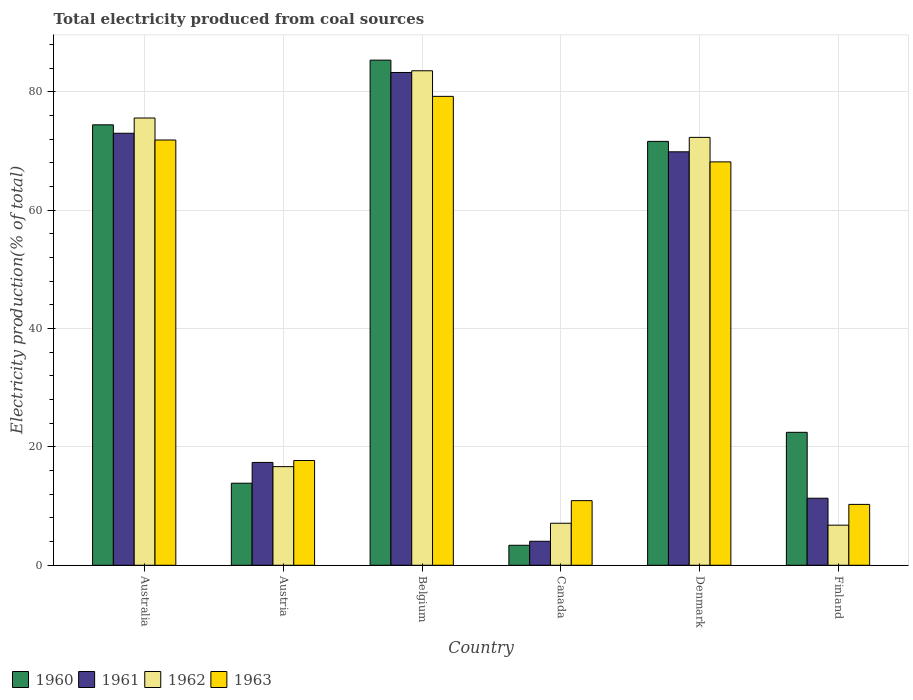Are the number of bars per tick equal to the number of legend labels?
Provide a short and direct response. Yes. Are the number of bars on each tick of the X-axis equal?
Your answer should be very brief. Yes. How many bars are there on the 2nd tick from the left?
Ensure brevity in your answer.  4. In how many cases, is the number of bars for a given country not equal to the number of legend labels?
Your answer should be very brief. 0. What is the total electricity produced in 1960 in Canada?
Provide a short and direct response. 3.38. Across all countries, what is the maximum total electricity produced in 1960?
Make the answer very short. 85.36. Across all countries, what is the minimum total electricity produced in 1960?
Your answer should be very brief. 3.38. In which country was the total electricity produced in 1962 maximum?
Make the answer very short. Belgium. What is the total total electricity produced in 1962 in the graph?
Provide a succinct answer. 261.97. What is the difference between the total electricity produced in 1960 in Austria and that in Canada?
Keep it short and to the point. 10.49. What is the difference between the total electricity produced in 1961 in Finland and the total electricity produced in 1963 in Denmark?
Offer a very short reply. -56.83. What is the average total electricity produced in 1963 per country?
Keep it short and to the point. 43.03. What is the difference between the total electricity produced of/in 1962 and total electricity produced of/in 1960 in Denmark?
Your answer should be very brief. 0.68. In how many countries, is the total electricity produced in 1960 greater than 20 %?
Your response must be concise. 4. What is the ratio of the total electricity produced in 1961 in Austria to that in Canada?
Give a very brief answer. 4.29. Is the difference between the total electricity produced in 1962 in Austria and Finland greater than the difference between the total electricity produced in 1960 in Austria and Finland?
Provide a short and direct response. Yes. What is the difference between the highest and the second highest total electricity produced in 1961?
Your answer should be very brief. -10.27. What is the difference between the highest and the lowest total electricity produced in 1960?
Ensure brevity in your answer.  81.98. Is it the case that in every country, the sum of the total electricity produced in 1961 and total electricity produced in 1963 is greater than the sum of total electricity produced in 1962 and total electricity produced in 1960?
Provide a succinct answer. No. Is it the case that in every country, the sum of the total electricity produced in 1960 and total electricity produced in 1961 is greater than the total electricity produced in 1962?
Your answer should be compact. Yes. Are all the bars in the graph horizontal?
Make the answer very short. No. What is the difference between two consecutive major ticks on the Y-axis?
Provide a short and direct response. 20. Are the values on the major ticks of Y-axis written in scientific E-notation?
Ensure brevity in your answer.  No. Where does the legend appear in the graph?
Your answer should be compact. Bottom left. What is the title of the graph?
Ensure brevity in your answer.  Total electricity produced from coal sources. What is the Electricity production(% of total) of 1960 in Australia?
Provide a succinct answer. 74.42. What is the Electricity production(% of total) of 1961 in Australia?
Provide a short and direct response. 73. What is the Electricity production(% of total) in 1962 in Australia?
Keep it short and to the point. 75.58. What is the Electricity production(% of total) in 1963 in Australia?
Provide a short and direct response. 71.86. What is the Electricity production(% of total) of 1960 in Austria?
Provide a short and direct response. 13.86. What is the Electricity production(% of total) of 1961 in Austria?
Provide a succinct answer. 17.38. What is the Electricity production(% of total) of 1962 in Austria?
Give a very brief answer. 16.66. What is the Electricity production(% of total) in 1963 in Austria?
Make the answer very short. 17.7. What is the Electricity production(% of total) in 1960 in Belgium?
Your response must be concise. 85.36. What is the Electricity production(% of total) of 1961 in Belgium?
Your response must be concise. 83.27. What is the Electricity production(% of total) of 1962 in Belgium?
Keep it short and to the point. 83.56. What is the Electricity production(% of total) in 1963 in Belgium?
Keep it short and to the point. 79.23. What is the Electricity production(% of total) in 1960 in Canada?
Make the answer very short. 3.38. What is the Electricity production(% of total) of 1961 in Canada?
Provide a succinct answer. 4.05. What is the Electricity production(% of total) in 1962 in Canada?
Provide a short and direct response. 7.1. What is the Electricity production(% of total) of 1963 in Canada?
Your answer should be compact. 10.92. What is the Electricity production(% of total) in 1960 in Denmark?
Your response must be concise. 71.62. What is the Electricity production(% of total) in 1961 in Denmark?
Give a very brief answer. 69.86. What is the Electricity production(% of total) in 1962 in Denmark?
Ensure brevity in your answer.  72.3. What is the Electricity production(% of total) in 1963 in Denmark?
Your response must be concise. 68.16. What is the Electricity production(% of total) in 1960 in Finland?
Your answer should be very brief. 22.46. What is the Electricity production(% of total) of 1961 in Finland?
Give a very brief answer. 11.33. What is the Electricity production(% of total) of 1962 in Finland?
Make the answer very short. 6.78. What is the Electricity production(% of total) in 1963 in Finland?
Offer a very short reply. 10.28. Across all countries, what is the maximum Electricity production(% of total) of 1960?
Give a very brief answer. 85.36. Across all countries, what is the maximum Electricity production(% of total) in 1961?
Make the answer very short. 83.27. Across all countries, what is the maximum Electricity production(% of total) of 1962?
Ensure brevity in your answer.  83.56. Across all countries, what is the maximum Electricity production(% of total) in 1963?
Provide a short and direct response. 79.23. Across all countries, what is the minimum Electricity production(% of total) of 1960?
Your answer should be compact. 3.38. Across all countries, what is the minimum Electricity production(% of total) in 1961?
Your response must be concise. 4.05. Across all countries, what is the minimum Electricity production(% of total) in 1962?
Your response must be concise. 6.78. Across all countries, what is the minimum Electricity production(% of total) of 1963?
Keep it short and to the point. 10.28. What is the total Electricity production(% of total) in 1960 in the graph?
Provide a succinct answer. 271.11. What is the total Electricity production(% of total) in 1961 in the graph?
Your response must be concise. 258.89. What is the total Electricity production(% of total) of 1962 in the graph?
Provide a short and direct response. 261.97. What is the total Electricity production(% of total) in 1963 in the graph?
Your answer should be very brief. 258.15. What is the difference between the Electricity production(% of total) in 1960 in Australia and that in Austria?
Provide a succinct answer. 60.56. What is the difference between the Electricity production(% of total) of 1961 in Australia and that in Austria?
Your answer should be very brief. 55.62. What is the difference between the Electricity production(% of total) of 1962 in Australia and that in Austria?
Give a very brief answer. 58.91. What is the difference between the Electricity production(% of total) of 1963 in Australia and that in Austria?
Provide a succinct answer. 54.16. What is the difference between the Electricity production(% of total) in 1960 in Australia and that in Belgium?
Your answer should be very brief. -10.93. What is the difference between the Electricity production(% of total) of 1961 in Australia and that in Belgium?
Keep it short and to the point. -10.27. What is the difference between the Electricity production(% of total) of 1962 in Australia and that in Belgium?
Provide a succinct answer. -7.98. What is the difference between the Electricity production(% of total) of 1963 in Australia and that in Belgium?
Make the answer very short. -7.37. What is the difference between the Electricity production(% of total) of 1960 in Australia and that in Canada?
Offer a very short reply. 71.05. What is the difference between the Electricity production(% of total) in 1961 in Australia and that in Canada?
Offer a very short reply. 68.94. What is the difference between the Electricity production(% of total) of 1962 in Australia and that in Canada?
Give a very brief answer. 68.48. What is the difference between the Electricity production(% of total) of 1963 in Australia and that in Canada?
Offer a very short reply. 60.94. What is the difference between the Electricity production(% of total) in 1960 in Australia and that in Denmark?
Ensure brevity in your answer.  2.8. What is the difference between the Electricity production(% of total) in 1961 in Australia and that in Denmark?
Provide a short and direct response. 3.13. What is the difference between the Electricity production(% of total) in 1962 in Australia and that in Denmark?
Your response must be concise. 3.27. What is the difference between the Electricity production(% of total) of 1963 in Australia and that in Denmark?
Provide a succinct answer. 3.7. What is the difference between the Electricity production(% of total) in 1960 in Australia and that in Finland?
Provide a succinct answer. 51.96. What is the difference between the Electricity production(% of total) of 1961 in Australia and that in Finland?
Your answer should be very brief. 61.67. What is the difference between the Electricity production(% of total) of 1962 in Australia and that in Finland?
Give a very brief answer. 68.8. What is the difference between the Electricity production(% of total) of 1963 in Australia and that in Finland?
Offer a very short reply. 61.57. What is the difference between the Electricity production(% of total) in 1960 in Austria and that in Belgium?
Provide a short and direct response. -71.49. What is the difference between the Electricity production(% of total) in 1961 in Austria and that in Belgium?
Keep it short and to the point. -65.89. What is the difference between the Electricity production(% of total) of 1962 in Austria and that in Belgium?
Provide a short and direct response. -66.89. What is the difference between the Electricity production(% of total) in 1963 in Austria and that in Belgium?
Your answer should be compact. -61.53. What is the difference between the Electricity production(% of total) in 1960 in Austria and that in Canada?
Make the answer very short. 10.49. What is the difference between the Electricity production(% of total) of 1961 in Austria and that in Canada?
Give a very brief answer. 13.32. What is the difference between the Electricity production(% of total) in 1962 in Austria and that in Canada?
Your response must be concise. 9.57. What is the difference between the Electricity production(% of total) in 1963 in Austria and that in Canada?
Keep it short and to the point. 6.79. What is the difference between the Electricity production(% of total) in 1960 in Austria and that in Denmark?
Give a very brief answer. -57.76. What is the difference between the Electricity production(% of total) of 1961 in Austria and that in Denmark?
Offer a very short reply. -52.49. What is the difference between the Electricity production(% of total) in 1962 in Austria and that in Denmark?
Your answer should be compact. -55.64. What is the difference between the Electricity production(% of total) in 1963 in Austria and that in Denmark?
Keep it short and to the point. -50.46. What is the difference between the Electricity production(% of total) of 1960 in Austria and that in Finland?
Keep it short and to the point. -8.6. What is the difference between the Electricity production(% of total) of 1961 in Austria and that in Finland?
Ensure brevity in your answer.  6.05. What is the difference between the Electricity production(% of total) in 1962 in Austria and that in Finland?
Provide a short and direct response. 9.89. What is the difference between the Electricity production(% of total) in 1963 in Austria and that in Finland?
Your answer should be very brief. 7.42. What is the difference between the Electricity production(% of total) in 1960 in Belgium and that in Canada?
Provide a succinct answer. 81.98. What is the difference between the Electricity production(% of total) in 1961 in Belgium and that in Canada?
Provide a succinct answer. 79.21. What is the difference between the Electricity production(% of total) of 1962 in Belgium and that in Canada?
Your answer should be compact. 76.46. What is the difference between the Electricity production(% of total) of 1963 in Belgium and that in Canada?
Your answer should be compact. 68.31. What is the difference between the Electricity production(% of total) of 1960 in Belgium and that in Denmark?
Offer a terse response. 13.73. What is the difference between the Electricity production(% of total) of 1961 in Belgium and that in Denmark?
Keep it short and to the point. 13.4. What is the difference between the Electricity production(% of total) in 1962 in Belgium and that in Denmark?
Provide a short and direct response. 11.26. What is the difference between the Electricity production(% of total) of 1963 in Belgium and that in Denmark?
Keep it short and to the point. 11.07. What is the difference between the Electricity production(% of total) of 1960 in Belgium and that in Finland?
Your response must be concise. 62.89. What is the difference between the Electricity production(% of total) of 1961 in Belgium and that in Finland?
Provide a succinct answer. 71.94. What is the difference between the Electricity production(% of total) in 1962 in Belgium and that in Finland?
Ensure brevity in your answer.  76.78. What is the difference between the Electricity production(% of total) in 1963 in Belgium and that in Finland?
Make the answer very short. 68.95. What is the difference between the Electricity production(% of total) in 1960 in Canada and that in Denmark?
Keep it short and to the point. -68.25. What is the difference between the Electricity production(% of total) of 1961 in Canada and that in Denmark?
Provide a short and direct response. -65.81. What is the difference between the Electricity production(% of total) of 1962 in Canada and that in Denmark?
Give a very brief answer. -65.2. What is the difference between the Electricity production(% of total) of 1963 in Canada and that in Denmark?
Keep it short and to the point. -57.24. What is the difference between the Electricity production(% of total) in 1960 in Canada and that in Finland?
Offer a terse response. -19.09. What is the difference between the Electricity production(% of total) in 1961 in Canada and that in Finland?
Offer a terse response. -7.27. What is the difference between the Electricity production(% of total) in 1962 in Canada and that in Finland?
Provide a short and direct response. 0.32. What is the difference between the Electricity production(% of total) of 1963 in Canada and that in Finland?
Ensure brevity in your answer.  0.63. What is the difference between the Electricity production(% of total) in 1960 in Denmark and that in Finland?
Offer a terse response. 49.16. What is the difference between the Electricity production(% of total) in 1961 in Denmark and that in Finland?
Your answer should be very brief. 58.54. What is the difference between the Electricity production(% of total) in 1962 in Denmark and that in Finland?
Offer a very short reply. 65.53. What is the difference between the Electricity production(% of total) of 1963 in Denmark and that in Finland?
Your answer should be compact. 57.88. What is the difference between the Electricity production(% of total) of 1960 in Australia and the Electricity production(% of total) of 1961 in Austria?
Make the answer very short. 57.05. What is the difference between the Electricity production(% of total) of 1960 in Australia and the Electricity production(% of total) of 1962 in Austria?
Provide a short and direct response. 57.76. What is the difference between the Electricity production(% of total) of 1960 in Australia and the Electricity production(% of total) of 1963 in Austria?
Offer a terse response. 56.72. What is the difference between the Electricity production(% of total) of 1961 in Australia and the Electricity production(% of total) of 1962 in Austria?
Ensure brevity in your answer.  56.33. What is the difference between the Electricity production(% of total) of 1961 in Australia and the Electricity production(% of total) of 1963 in Austria?
Your answer should be very brief. 55.3. What is the difference between the Electricity production(% of total) of 1962 in Australia and the Electricity production(% of total) of 1963 in Austria?
Provide a short and direct response. 57.87. What is the difference between the Electricity production(% of total) of 1960 in Australia and the Electricity production(% of total) of 1961 in Belgium?
Give a very brief answer. -8.84. What is the difference between the Electricity production(% of total) of 1960 in Australia and the Electricity production(% of total) of 1962 in Belgium?
Your response must be concise. -9.13. What is the difference between the Electricity production(% of total) of 1960 in Australia and the Electricity production(% of total) of 1963 in Belgium?
Give a very brief answer. -4.81. What is the difference between the Electricity production(% of total) of 1961 in Australia and the Electricity production(% of total) of 1962 in Belgium?
Your answer should be very brief. -10.56. What is the difference between the Electricity production(% of total) of 1961 in Australia and the Electricity production(% of total) of 1963 in Belgium?
Your answer should be very brief. -6.23. What is the difference between the Electricity production(% of total) of 1962 in Australia and the Electricity production(% of total) of 1963 in Belgium?
Your response must be concise. -3.66. What is the difference between the Electricity production(% of total) in 1960 in Australia and the Electricity production(% of total) in 1961 in Canada?
Your response must be concise. 70.37. What is the difference between the Electricity production(% of total) in 1960 in Australia and the Electricity production(% of total) in 1962 in Canada?
Your answer should be very brief. 67.32. What is the difference between the Electricity production(% of total) of 1960 in Australia and the Electricity production(% of total) of 1963 in Canada?
Offer a very short reply. 63.51. What is the difference between the Electricity production(% of total) of 1961 in Australia and the Electricity production(% of total) of 1962 in Canada?
Your response must be concise. 65.9. What is the difference between the Electricity production(% of total) of 1961 in Australia and the Electricity production(% of total) of 1963 in Canada?
Provide a succinct answer. 62.08. What is the difference between the Electricity production(% of total) in 1962 in Australia and the Electricity production(% of total) in 1963 in Canada?
Keep it short and to the point. 64.66. What is the difference between the Electricity production(% of total) of 1960 in Australia and the Electricity production(% of total) of 1961 in Denmark?
Offer a very short reply. 4.56. What is the difference between the Electricity production(% of total) of 1960 in Australia and the Electricity production(% of total) of 1962 in Denmark?
Make the answer very short. 2.12. What is the difference between the Electricity production(% of total) in 1960 in Australia and the Electricity production(% of total) in 1963 in Denmark?
Your response must be concise. 6.26. What is the difference between the Electricity production(% of total) of 1961 in Australia and the Electricity production(% of total) of 1962 in Denmark?
Your answer should be compact. 0.7. What is the difference between the Electricity production(% of total) of 1961 in Australia and the Electricity production(% of total) of 1963 in Denmark?
Make the answer very short. 4.84. What is the difference between the Electricity production(% of total) of 1962 in Australia and the Electricity production(% of total) of 1963 in Denmark?
Give a very brief answer. 7.41. What is the difference between the Electricity production(% of total) in 1960 in Australia and the Electricity production(% of total) in 1961 in Finland?
Give a very brief answer. 63.1. What is the difference between the Electricity production(% of total) of 1960 in Australia and the Electricity production(% of total) of 1962 in Finland?
Offer a very short reply. 67.65. What is the difference between the Electricity production(% of total) of 1960 in Australia and the Electricity production(% of total) of 1963 in Finland?
Your response must be concise. 64.14. What is the difference between the Electricity production(% of total) in 1961 in Australia and the Electricity production(% of total) in 1962 in Finland?
Make the answer very short. 66.22. What is the difference between the Electricity production(% of total) in 1961 in Australia and the Electricity production(% of total) in 1963 in Finland?
Keep it short and to the point. 62.72. What is the difference between the Electricity production(% of total) of 1962 in Australia and the Electricity production(% of total) of 1963 in Finland?
Your answer should be compact. 65.29. What is the difference between the Electricity production(% of total) in 1960 in Austria and the Electricity production(% of total) in 1961 in Belgium?
Ensure brevity in your answer.  -69.4. What is the difference between the Electricity production(% of total) of 1960 in Austria and the Electricity production(% of total) of 1962 in Belgium?
Provide a short and direct response. -69.69. What is the difference between the Electricity production(% of total) in 1960 in Austria and the Electricity production(% of total) in 1963 in Belgium?
Ensure brevity in your answer.  -65.37. What is the difference between the Electricity production(% of total) of 1961 in Austria and the Electricity production(% of total) of 1962 in Belgium?
Give a very brief answer. -66.18. What is the difference between the Electricity production(% of total) in 1961 in Austria and the Electricity production(% of total) in 1963 in Belgium?
Ensure brevity in your answer.  -61.86. What is the difference between the Electricity production(% of total) of 1962 in Austria and the Electricity production(% of total) of 1963 in Belgium?
Give a very brief answer. -62.57. What is the difference between the Electricity production(% of total) of 1960 in Austria and the Electricity production(% of total) of 1961 in Canada?
Provide a succinct answer. 9.81. What is the difference between the Electricity production(% of total) in 1960 in Austria and the Electricity production(% of total) in 1962 in Canada?
Offer a very short reply. 6.77. What is the difference between the Electricity production(% of total) in 1960 in Austria and the Electricity production(% of total) in 1963 in Canada?
Provide a short and direct response. 2.95. What is the difference between the Electricity production(% of total) of 1961 in Austria and the Electricity production(% of total) of 1962 in Canada?
Give a very brief answer. 10.28. What is the difference between the Electricity production(% of total) of 1961 in Austria and the Electricity production(% of total) of 1963 in Canada?
Make the answer very short. 6.46. What is the difference between the Electricity production(% of total) in 1962 in Austria and the Electricity production(% of total) in 1963 in Canada?
Offer a very short reply. 5.75. What is the difference between the Electricity production(% of total) in 1960 in Austria and the Electricity production(% of total) in 1961 in Denmark?
Your response must be concise. -56. What is the difference between the Electricity production(% of total) of 1960 in Austria and the Electricity production(% of total) of 1962 in Denmark?
Offer a very short reply. -58.44. What is the difference between the Electricity production(% of total) of 1960 in Austria and the Electricity production(% of total) of 1963 in Denmark?
Provide a succinct answer. -54.3. What is the difference between the Electricity production(% of total) in 1961 in Austria and the Electricity production(% of total) in 1962 in Denmark?
Your answer should be very brief. -54.92. What is the difference between the Electricity production(% of total) in 1961 in Austria and the Electricity production(% of total) in 1963 in Denmark?
Give a very brief answer. -50.78. What is the difference between the Electricity production(% of total) of 1962 in Austria and the Electricity production(% of total) of 1963 in Denmark?
Ensure brevity in your answer.  -51.5. What is the difference between the Electricity production(% of total) in 1960 in Austria and the Electricity production(% of total) in 1961 in Finland?
Provide a short and direct response. 2.54. What is the difference between the Electricity production(% of total) in 1960 in Austria and the Electricity production(% of total) in 1962 in Finland?
Make the answer very short. 7.09. What is the difference between the Electricity production(% of total) of 1960 in Austria and the Electricity production(% of total) of 1963 in Finland?
Your response must be concise. 3.58. What is the difference between the Electricity production(% of total) in 1961 in Austria and the Electricity production(% of total) in 1962 in Finland?
Provide a short and direct response. 10.6. What is the difference between the Electricity production(% of total) of 1961 in Austria and the Electricity production(% of total) of 1963 in Finland?
Keep it short and to the point. 7.09. What is the difference between the Electricity production(% of total) of 1962 in Austria and the Electricity production(% of total) of 1963 in Finland?
Offer a very short reply. 6.38. What is the difference between the Electricity production(% of total) of 1960 in Belgium and the Electricity production(% of total) of 1961 in Canada?
Your response must be concise. 81.3. What is the difference between the Electricity production(% of total) of 1960 in Belgium and the Electricity production(% of total) of 1962 in Canada?
Your response must be concise. 78.26. What is the difference between the Electricity production(% of total) of 1960 in Belgium and the Electricity production(% of total) of 1963 in Canada?
Your response must be concise. 74.44. What is the difference between the Electricity production(% of total) in 1961 in Belgium and the Electricity production(% of total) in 1962 in Canada?
Offer a very short reply. 76.17. What is the difference between the Electricity production(% of total) in 1961 in Belgium and the Electricity production(% of total) in 1963 in Canada?
Make the answer very short. 72.35. What is the difference between the Electricity production(% of total) of 1962 in Belgium and the Electricity production(% of total) of 1963 in Canada?
Give a very brief answer. 72.64. What is the difference between the Electricity production(% of total) in 1960 in Belgium and the Electricity production(% of total) in 1961 in Denmark?
Offer a terse response. 15.49. What is the difference between the Electricity production(% of total) of 1960 in Belgium and the Electricity production(% of total) of 1962 in Denmark?
Keep it short and to the point. 13.05. What is the difference between the Electricity production(% of total) of 1960 in Belgium and the Electricity production(% of total) of 1963 in Denmark?
Offer a terse response. 17.19. What is the difference between the Electricity production(% of total) in 1961 in Belgium and the Electricity production(% of total) in 1962 in Denmark?
Ensure brevity in your answer.  10.97. What is the difference between the Electricity production(% of total) in 1961 in Belgium and the Electricity production(% of total) in 1963 in Denmark?
Give a very brief answer. 15.11. What is the difference between the Electricity production(% of total) in 1962 in Belgium and the Electricity production(% of total) in 1963 in Denmark?
Ensure brevity in your answer.  15.4. What is the difference between the Electricity production(% of total) of 1960 in Belgium and the Electricity production(% of total) of 1961 in Finland?
Provide a succinct answer. 74.03. What is the difference between the Electricity production(% of total) in 1960 in Belgium and the Electricity production(% of total) in 1962 in Finland?
Your response must be concise. 78.58. What is the difference between the Electricity production(% of total) of 1960 in Belgium and the Electricity production(% of total) of 1963 in Finland?
Offer a terse response. 75.07. What is the difference between the Electricity production(% of total) of 1961 in Belgium and the Electricity production(% of total) of 1962 in Finland?
Give a very brief answer. 76.49. What is the difference between the Electricity production(% of total) of 1961 in Belgium and the Electricity production(% of total) of 1963 in Finland?
Keep it short and to the point. 72.98. What is the difference between the Electricity production(% of total) in 1962 in Belgium and the Electricity production(% of total) in 1963 in Finland?
Ensure brevity in your answer.  73.27. What is the difference between the Electricity production(% of total) of 1960 in Canada and the Electricity production(% of total) of 1961 in Denmark?
Offer a very short reply. -66.49. What is the difference between the Electricity production(% of total) in 1960 in Canada and the Electricity production(% of total) in 1962 in Denmark?
Offer a very short reply. -68.92. What is the difference between the Electricity production(% of total) in 1960 in Canada and the Electricity production(% of total) in 1963 in Denmark?
Ensure brevity in your answer.  -64.78. What is the difference between the Electricity production(% of total) in 1961 in Canada and the Electricity production(% of total) in 1962 in Denmark?
Offer a very short reply. -68.25. What is the difference between the Electricity production(% of total) in 1961 in Canada and the Electricity production(% of total) in 1963 in Denmark?
Provide a short and direct response. -64.11. What is the difference between the Electricity production(% of total) of 1962 in Canada and the Electricity production(% of total) of 1963 in Denmark?
Offer a very short reply. -61.06. What is the difference between the Electricity production(% of total) of 1960 in Canada and the Electricity production(% of total) of 1961 in Finland?
Your answer should be very brief. -7.95. What is the difference between the Electricity production(% of total) of 1960 in Canada and the Electricity production(% of total) of 1962 in Finland?
Provide a succinct answer. -3.4. What is the difference between the Electricity production(% of total) in 1960 in Canada and the Electricity production(% of total) in 1963 in Finland?
Your answer should be very brief. -6.91. What is the difference between the Electricity production(% of total) of 1961 in Canada and the Electricity production(% of total) of 1962 in Finland?
Your answer should be compact. -2.72. What is the difference between the Electricity production(% of total) in 1961 in Canada and the Electricity production(% of total) in 1963 in Finland?
Offer a very short reply. -6.23. What is the difference between the Electricity production(% of total) of 1962 in Canada and the Electricity production(% of total) of 1963 in Finland?
Ensure brevity in your answer.  -3.18. What is the difference between the Electricity production(% of total) of 1960 in Denmark and the Electricity production(% of total) of 1961 in Finland?
Give a very brief answer. 60.3. What is the difference between the Electricity production(% of total) in 1960 in Denmark and the Electricity production(% of total) in 1962 in Finland?
Your response must be concise. 64.85. What is the difference between the Electricity production(% of total) in 1960 in Denmark and the Electricity production(% of total) in 1963 in Finland?
Give a very brief answer. 61.34. What is the difference between the Electricity production(% of total) of 1961 in Denmark and the Electricity production(% of total) of 1962 in Finland?
Give a very brief answer. 63.09. What is the difference between the Electricity production(% of total) in 1961 in Denmark and the Electricity production(% of total) in 1963 in Finland?
Your response must be concise. 59.58. What is the difference between the Electricity production(% of total) in 1962 in Denmark and the Electricity production(% of total) in 1963 in Finland?
Your answer should be very brief. 62.02. What is the average Electricity production(% of total) of 1960 per country?
Keep it short and to the point. 45.18. What is the average Electricity production(% of total) of 1961 per country?
Provide a short and direct response. 43.15. What is the average Electricity production(% of total) in 1962 per country?
Offer a very short reply. 43.66. What is the average Electricity production(% of total) of 1963 per country?
Your response must be concise. 43.03. What is the difference between the Electricity production(% of total) in 1960 and Electricity production(% of total) in 1961 in Australia?
Ensure brevity in your answer.  1.42. What is the difference between the Electricity production(% of total) in 1960 and Electricity production(% of total) in 1962 in Australia?
Ensure brevity in your answer.  -1.15. What is the difference between the Electricity production(% of total) of 1960 and Electricity production(% of total) of 1963 in Australia?
Provide a succinct answer. 2.57. What is the difference between the Electricity production(% of total) in 1961 and Electricity production(% of total) in 1962 in Australia?
Ensure brevity in your answer.  -2.58. What is the difference between the Electricity production(% of total) of 1961 and Electricity production(% of total) of 1963 in Australia?
Your response must be concise. 1.14. What is the difference between the Electricity production(% of total) of 1962 and Electricity production(% of total) of 1963 in Australia?
Offer a terse response. 3.72. What is the difference between the Electricity production(% of total) in 1960 and Electricity production(% of total) in 1961 in Austria?
Offer a terse response. -3.51. What is the difference between the Electricity production(% of total) of 1960 and Electricity production(% of total) of 1963 in Austria?
Your answer should be very brief. -3.84. What is the difference between the Electricity production(% of total) of 1961 and Electricity production(% of total) of 1962 in Austria?
Your response must be concise. 0.71. What is the difference between the Electricity production(% of total) in 1961 and Electricity production(% of total) in 1963 in Austria?
Provide a short and direct response. -0.33. What is the difference between the Electricity production(% of total) in 1962 and Electricity production(% of total) in 1963 in Austria?
Your answer should be very brief. -1.04. What is the difference between the Electricity production(% of total) of 1960 and Electricity production(% of total) of 1961 in Belgium?
Provide a short and direct response. 2.09. What is the difference between the Electricity production(% of total) of 1960 and Electricity production(% of total) of 1962 in Belgium?
Give a very brief answer. 1.8. What is the difference between the Electricity production(% of total) of 1960 and Electricity production(% of total) of 1963 in Belgium?
Your answer should be very brief. 6.12. What is the difference between the Electricity production(% of total) in 1961 and Electricity production(% of total) in 1962 in Belgium?
Your answer should be compact. -0.29. What is the difference between the Electricity production(% of total) in 1961 and Electricity production(% of total) in 1963 in Belgium?
Your answer should be very brief. 4.04. What is the difference between the Electricity production(% of total) of 1962 and Electricity production(% of total) of 1963 in Belgium?
Give a very brief answer. 4.33. What is the difference between the Electricity production(% of total) of 1960 and Electricity production(% of total) of 1961 in Canada?
Your answer should be compact. -0.68. What is the difference between the Electricity production(% of total) in 1960 and Electricity production(% of total) in 1962 in Canada?
Your answer should be compact. -3.72. What is the difference between the Electricity production(% of total) of 1960 and Electricity production(% of total) of 1963 in Canada?
Your answer should be very brief. -7.54. What is the difference between the Electricity production(% of total) in 1961 and Electricity production(% of total) in 1962 in Canada?
Provide a succinct answer. -3.04. What is the difference between the Electricity production(% of total) in 1961 and Electricity production(% of total) in 1963 in Canada?
Your response must be concise. -6.86. What is the difference between the Electricity production(% of total) of 1962 and Electricity production(% of total) of 1963 in Canada?
Make the answer very short. -3.82. What is the difference between the Electricity production(% of total) of 1960 and Electricity production(% of total) of 1961 in Denmark?
Provide a short and direct response. 1.76. What is the difference between the Electricity production(% of total) in 1960 and Electricity production(% of total) in 1962 in Denmark?
Keep it short and to the point. -0.68. What is the difference between the Electricity production(% of total) of 1960 and Electricity production(% of total) of 1963 in Denmark?
Give a very brief answer. 3.46. What is the difference between the Electricity production(% of total) in 1961 and Electricity production(% of total) in 1962 in Denmark?
Your answer should be very brief. -2.44. What is the difference between the Electricity production(% of total) of 1961 and Electricity production(% of total) of 1963 in Denmark?
Provide a short and direct response. 1.7. What is the difference between the Electricity production(% of total) in 1962 and Electricity production(% of total) in 1963 in Denmark?
Ensure brevity in your answer.  4.14. What is the difference between the Electricity production(% of total) of 1960 and Electricity production(% of total) of 1961 in Finland?
Provide a short and direct response. 11.14. What is the difference between the Electricity production(% of total) of 1960 and Electricity production(% of total) of 1962 in Finland?
Offer a very short reply. 15.69. What is the difference between the Electricity production(% of total) in 1960 and Electricity production(% of total) in 1963 in Finland?
Your response must be concise. 12.18. What is the difference between the Electricity production(% of total) of 1961 and Electricity production(% of total) of 1962 in Finland?
Your response must be concise. 4.55. What is the difference between the Electricity production(% of total) in 1961 and Electricity production(% of total) in 1963 in Finland?
Ensure brevity in your answer.  1.04. What is the difference between the Electricity production(% of total) of 1962 and Electricity production(% of total) of 1963 in Finland?
Your answer should be very brief. -3.51. What is the ratio of the Electricity production(% of total) in 1960 in Australia to that in Austria?
Make the answer very short. 5.37. What is the ratio of the Electricity production(% of total) of 1961 in Australia to that in Austria?
Ensure brevity in your answer.  4.2. What is the ratio of the Electricity production(% of total) of 1962 in Australia to that in Austria?
Give a very brief answer. 4.54. What is the ratio of the Electricity production(% of total) in 1963 in Australia to that in Austria?
Provide a succinct answer. 4.06. What is the ratio of the Electricity production(% of total) in 1960 in Australia to that in Belgium?
Offer a very short reply. 0.87. What is the ratio of the Electricity production(% of total) of 1961 in Australia to that in Belgium?
Offer a terse response. 0.88. What is the ratio of the Electricity production(% of total) in 1962 in Australia to that in Belgium?
Provide a short and direct response. 0.9. What is the ratio of the Electricity production(% of total) in 1963 in Australia to that in Belgium?
Provide a succinct answer. 0.91. What is the ratio of the Electricity production(% of total) in 1960 in Australia to that in Canada?
Offer a very short reply. 22.03. What is the ratio of the Electricity production(% of total) in 1961 in Australia to that in Canada?
Your answer should be very brief. 18.01. What is the ratio of the Electricity production(% of total) of 1962 in Australia to that in Canada?
Your answer should be compact. 10.65. What is the ratio of the Electricity production(% of total) of 1963 in Australia to that in Canada?
Your answer should be very brief. 6.58. What is the ratio of the Electricity production(% of total) of 1960 in Australia to that in Denmark?
Keep it short and to the point. 1.04. What is the ratio of the Electricity production(% of total) in 1961 in Australia to that in Denmark?
Your answer should be compact. 1.04. What is the ratio of the Electricity production(% of total) in 1962 in Australia to that in Denmark?
Provide a succinct answer. 1.05. What is the ratio of the Electricity production(% of total) in 1963 in Australia to that in Denmark?
Offer a very short reply. 1.05. What is the ratio of the Electricity production(% of total) in 1960 in Australia to that in Finland?
Provide a succinct answer. 3.31. What is the ratio of the Electricity production(% of total) of 1961 in Australia to that in Finland?
Make the answer very short. 6.44. What is the ratio of the Electricity production(% of total) of 1962 in Australia to that in Finland?
Provide a succinct answer. 11.15. What is the ratio of the Electricity production(% of total) of 1963 in Australia to that in Finland?
Make the answer very short. 6.99. What is the ratio of the Electricity production(% of total) in 1960 in Austria to that in Belgium?
Your response must be concise. 0.16. What is the ratio of the Electricity production(% of total) in 1961 in Austria to that in Belgium?
Provide a short and direct response. 0.21. What is the ratio of the Electricity production(% of total) of 1962 in Austria to that in Belgium?
Make the answer very short. 0.2. What is the ratio of the Electricity production(% of total) of 1963 in Austria to that in Belgium?
Provide a succinct answer. 0.22. What is the ratio of the Electricity production(% of total) in 1960 in Austria to that in Canada?
Offer a terse response. 4.1. What is the ratio of the Electricity production(% of total) of 1961 in Austria to that in Canada?
Your answer should be compact. 4.29. What is the ratio of the Electricity production(% of total) in 1962 in Austria to that in Canada?
Your answer should be compact. 2.35. What is the ratio of the Electricity production(% of total) of 1963 in Austria to that in Canada?
Your answer should be compact. 1.62. What is the ratio of the Electricity production(% of total) of 1960 in Austria to that in Denmark?
Keep it short and to the point. 0.19. What is the ratio of the Electricity production(% of total) of 1961 in Austria to that in Denmark?
Your answer should be very brief. 0.25. What is the ratio of the Electricity production(% of total) of 1962 in Austria to that in Denmark?
Your answer should be very brief. 0.23. What is the ratio of the Electricity production(% of total) of 1963 in Austria to that in Denmark?
Your answer should be compact. 0.26. What is the ratio of the Electricity production(% of total) in 1960 in Austria to that in Finland?
Keep it short and to the point. 0.62. What is the ratio of the Electricity production(% of total) in 1961 in Austria to that in Finland?
Provide a succinct answer. 1.53. What is the ratio of the Electricity production(% of total) in 1962 in Austria to that in Finland?
Offer a terse response. 2.46. What is the ratio of the Electricity production(% of total) of 1963 in Austria to that in Finland?
Your response must be concise. 1.72. What is the ratio of the Electricity production(% of total) in 1960 in Belgium to that in Canada?
Your answer should be compact. 25.27. What is the ratio of the Electricity production(% of total) of 1961 in Belgium to that in Canada?
Give a very brief answer. 20.54. What is the ratio of the Electricity production(% of total) of 1962 in Belgium to that in Canada?
Give a very brief answer. 11.77. What is the ratio of the Electricity production(% of total) of 1963 in Belgium to that in Canada?
Your answer should be compact. 7.26. What is the ratio of the Electricity production(% of total) of 1960 in Belgium to that in Denmark?
Make the answer very short. 1.19. What is the ratio of the Electricity production(% of total) in 1961 in Belgium to that in Denmark?
Your answer should be very brief. 1.19. What is the ratio of the Electricity production(% of total) of 1962 in Belgium to that in Denmark?
Make the answer very short. 1.16. What is the ratio of the Electricity production(% of total) of 1963 in Belgium to that in Denmark?
Your answer should be compact. 1.16. What is the ratio of the Electricity production(% of total) of 1960 in Belgium to that in Finland?
Offer a terse response. 3.8. What is the ratio of the Electricity production(% of total) in 1961 in Belgium to that in Finland?
Offer a very short reply. 7.35. What is the ratio of the Electricity production(% of total) in 1962 in Belgium to that in Finland?
Your answer should be very brief. 12.33. What is the ratio of the Electricity production(% of total) in 1963 in Belgium to that in Finland?
Your answer should be compact. 7.7. What is the ratio of the Electricity production(% of total) in 1960 in Canada to that in Denmark?
Provide a short and direct response. 0.05. What is the ratio of the Electricity production(% of total) in 1961 in Canada to that in Denmark?
Your answer should be compact. 0.06. What is the ratio of the Electricity production(% of total) of 1962 in Canada to that in Denmark?
Ensure brevity in your answer.  0.1. What is the ratio of the Electricity production(% of total) in 1963 in Canada to that in Denmark?
Provide a succinct answer. 0.16. What is the ratio of the Electricity production(% of total) of 1960 in Canada to that in Finland?
Provide a succinct answer. 0.15. What is the ratio of the Electricity production(% of total) of 1961 in Canada to that in Finland?
Keep it short and to the point. 0.36. What is the ratio of the Electricity production(% of total) in 1962 in Canada to that in Finland?
Offer a very short reply. 1.05. What is the ratio of the Electricity production(% of total) in 1963 in Canada to that in Finland?
Provide a short and direct response. 1.06. What is the ratio of the Electricity production(% of total) of 1960 in Denmark to that in Finland?
Your response must be concise. 3.19. What is the ratio of the Electricity production(% of total) in 1961 in Denmark to that in Finland?
Keep it short and to the point. 6.17. What is the ratio of the Electricity production(% of total) of 1962 in Denmark to that in Finland?
Provide a succinct answer. 10.67. What is the ratio of the Electricity production(% of total) in 1963 in Denmark to that in Finland?
Ensure brevity in your answer.  6.63. What is the difference between the highest and the second highest Electricity production(% of total) in 1960?
Keep it short and to the point. 10.93. What is the difference between the highest and the second highest Electricity production(% of total) of 1961?
Offer a terse response. 10.27. What is the difference between the highest and the second highest Electricity production(% of total) of 1962?
Offer a very short reply. 7.98. What is the difference between the highest and the second highest Electricity production(% of total) in 1963?
Provide a succinct answer. 7.37. What is the difference between the highest and the lowest Electricity production(% of total) in 1960?
Provide a short and direct response. 81.98. What is the difference between the highest and the lowest Electricity production(% of total) of 1961?
Your answer should be very brief. 79.21. What is the difference between the highest and the lowest Electricity production(% of total) in 1962?
Give a very brief answer. 76.78. What is the difference between the highest and the lowest Electricity production(% of total) in 1963?
Provide a succinct answer. 68.95. 